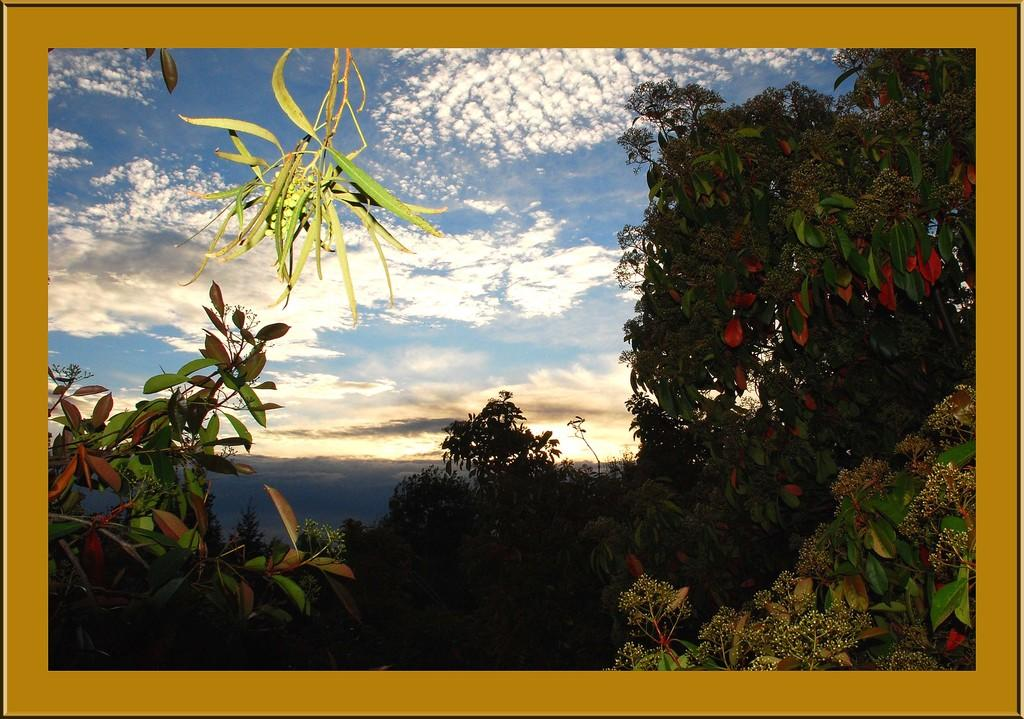What type of vegetation can be seen in the image? There are trees in the image. What part of the natural environment is visible in the image? The sky is visible in the image. What can be observed in the sky in the image? Clouds are present in the image. How many dolls are holding onto the trees in the image? There are no dolls present in the image, so it is not possible to determine how many might be holding onto the trees. 